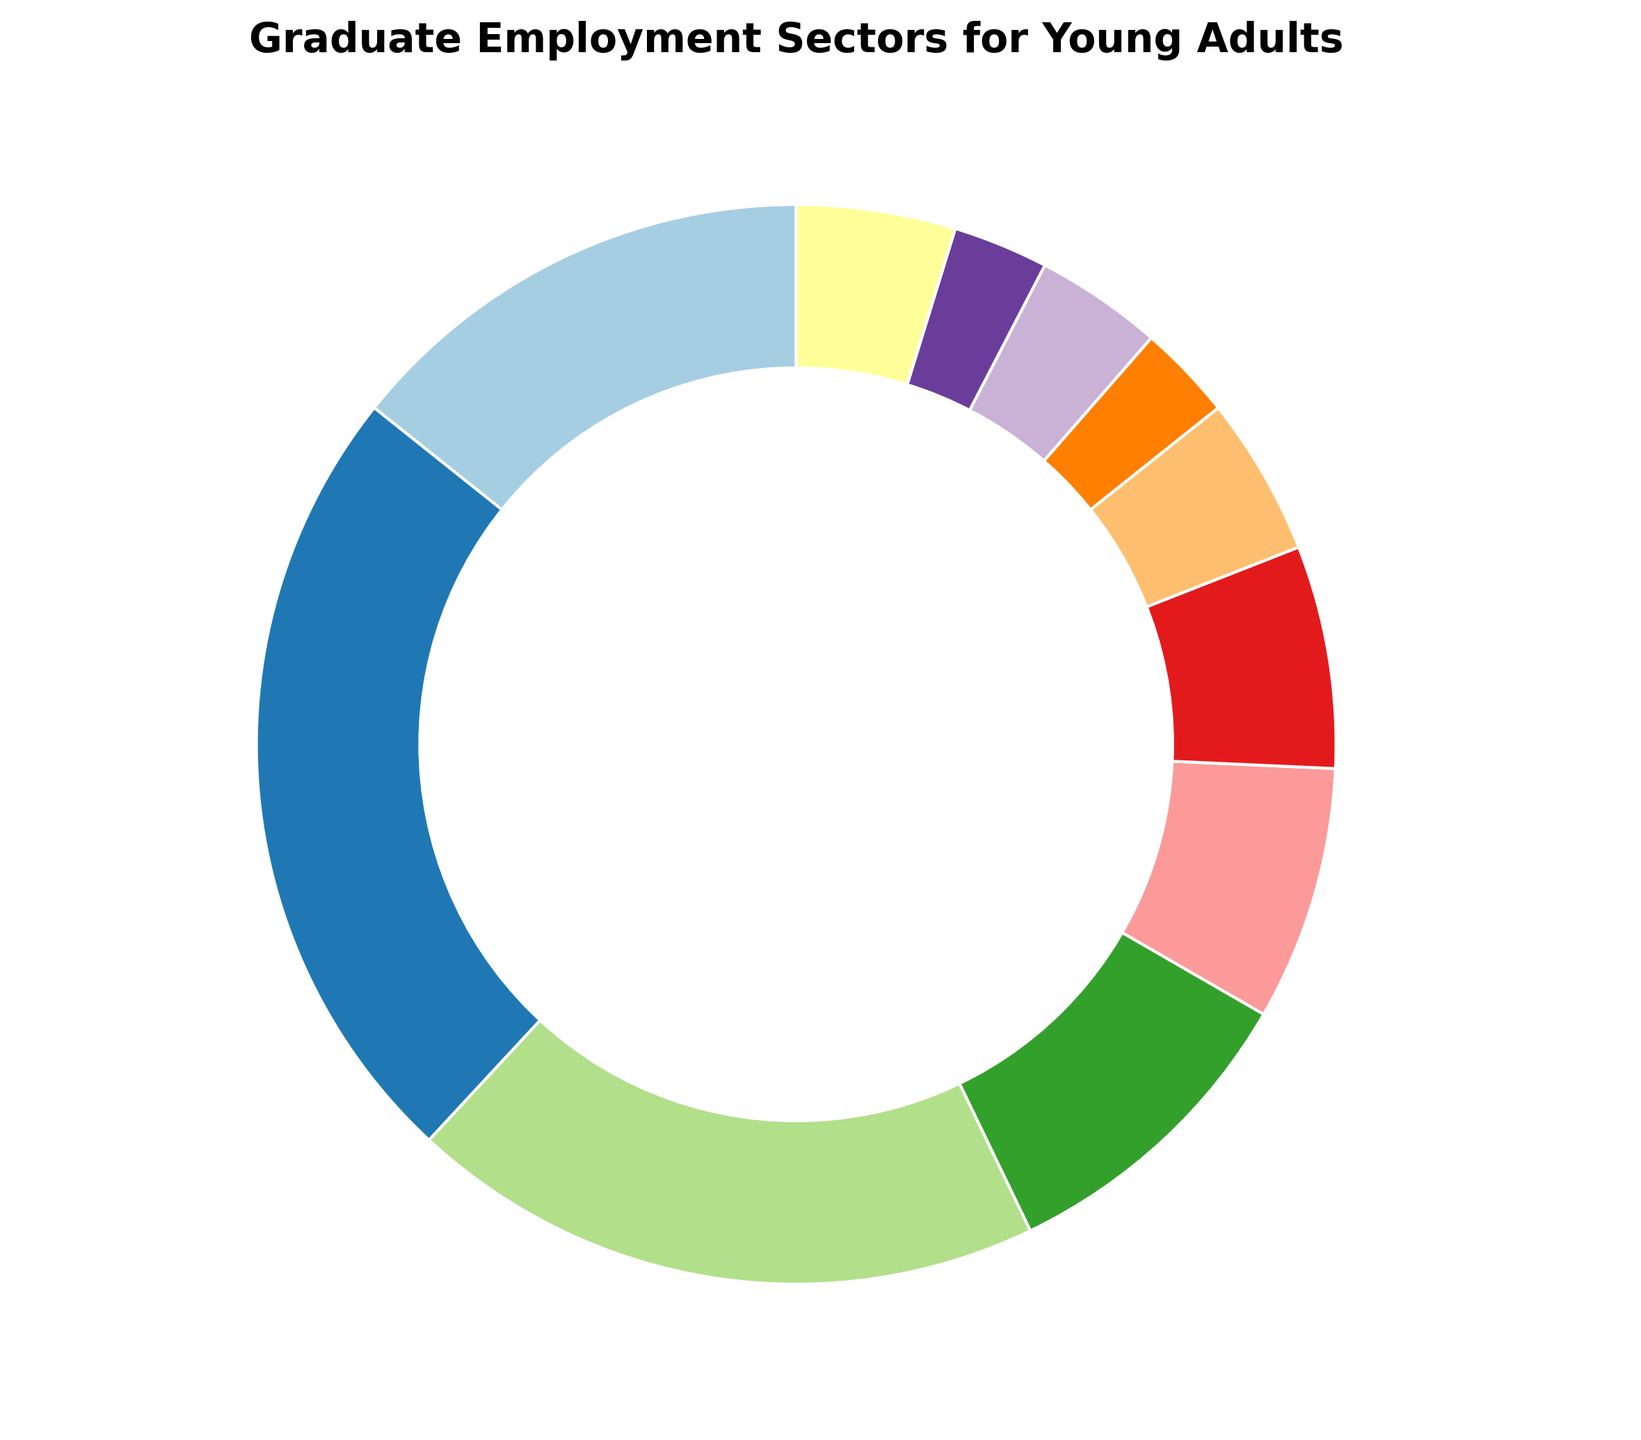What's the largest employment sector for young adults and what percentage does it represent? We need to identify the sector with the highest percentage. From the pie chart, Technology stands out as the largest sector with 25%.
Answer: Technology, 25% What's the combined percentage of young adults employed in Healthcare, Finance, and Retail sectors? Add the percentages of the three sectors: Healthcare (20%), Finance (10%), and Retail (8%). So, 20 + 10 + 8 = 38%.
Answer: 38% Which sector has the least representation, and what percentage does it hold? We need to identify the smallest slice of the pie chart. Arts and Entertainment and Nonprofit sectors are both the smallest, each holding 3%.
Answer: Arts and Entertainment, Nonprofit, 3% Is the percentage of young adults employed in Education greater than those in Hospitality and Government combined? Compare Education (15%) to Hospitality (4%) + Government (5%) which equals 9%; 15% is greater than 9%.
Answer: Yes What's the total percentage of young adults employed outside the top three sectors? Top three sectors are Technology (25%), Healthcare (20%), and Education (15%) amounting to 60%. Subtract this total from 100%: 100 - 60 = 40%.
Answer: 40% Which sector has a percentage closest to 10%, and what is the actual percentage? Identify the sector closest to 10%. Finance is exactly 10%.
Answer: Finance, 10% How does the percentage of young adults in Government compare to those in Other sectors? Compare Government (5%) to Other (5%). Both percentages are equal.
Answer: They are equal What's the difference in percentage between Technology and Manufacturing sectors? Subtract Manufacturing's percentage (7%) from Technology's percentage (25%): 25 - 7 = 18%.
Answer: 18% Do more young adults work in Retail than in Nonprofit and Arts and Entertainment sectors combined? Compare Retail (8%) with Nonprofit (3%) + Arts and Entertainment (3%) = 6%; 8% is greater than 6%.
Answer: Yes What’s the sum of percentages of sectors with 5% representation each? Identify the sectors with 5% representation: Government (5%) and Other (5%). So, the sum is 5 + 5 = 10%.
Answer: 10% 